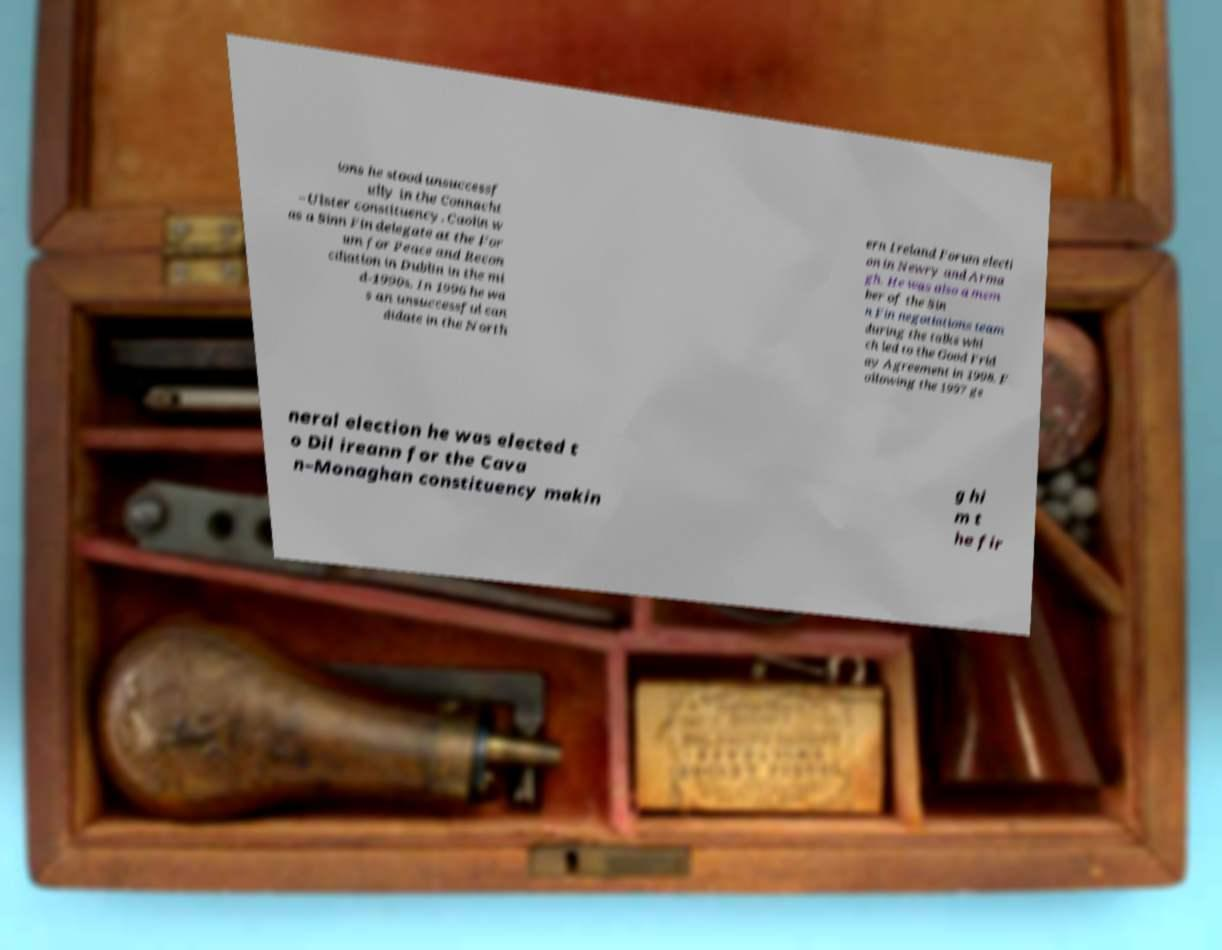For documentation purposes, I need the text within this image transcribed. Could you provide that? ions he stood unsuccessf ully in the Connacht –Ulster constituency. Caolin w as a Sinn Fin delegate at the For um for Peace and Recon ciliation in Dublin in the mi d-1990s. In 1996 he wa s an unsuccessful can didate in the North ern Ireland Forum electi on in Newry and Arma gh. He was also a mem ber of the Sin n Fin negotiations team during the talks whi ch led to the Good Frid ay Agreement in 1998. F ollowing the 1997 ge neral election he was elected t o Dil ireann for the Cava n–Monaghan constituency makin g hi m t he fir 